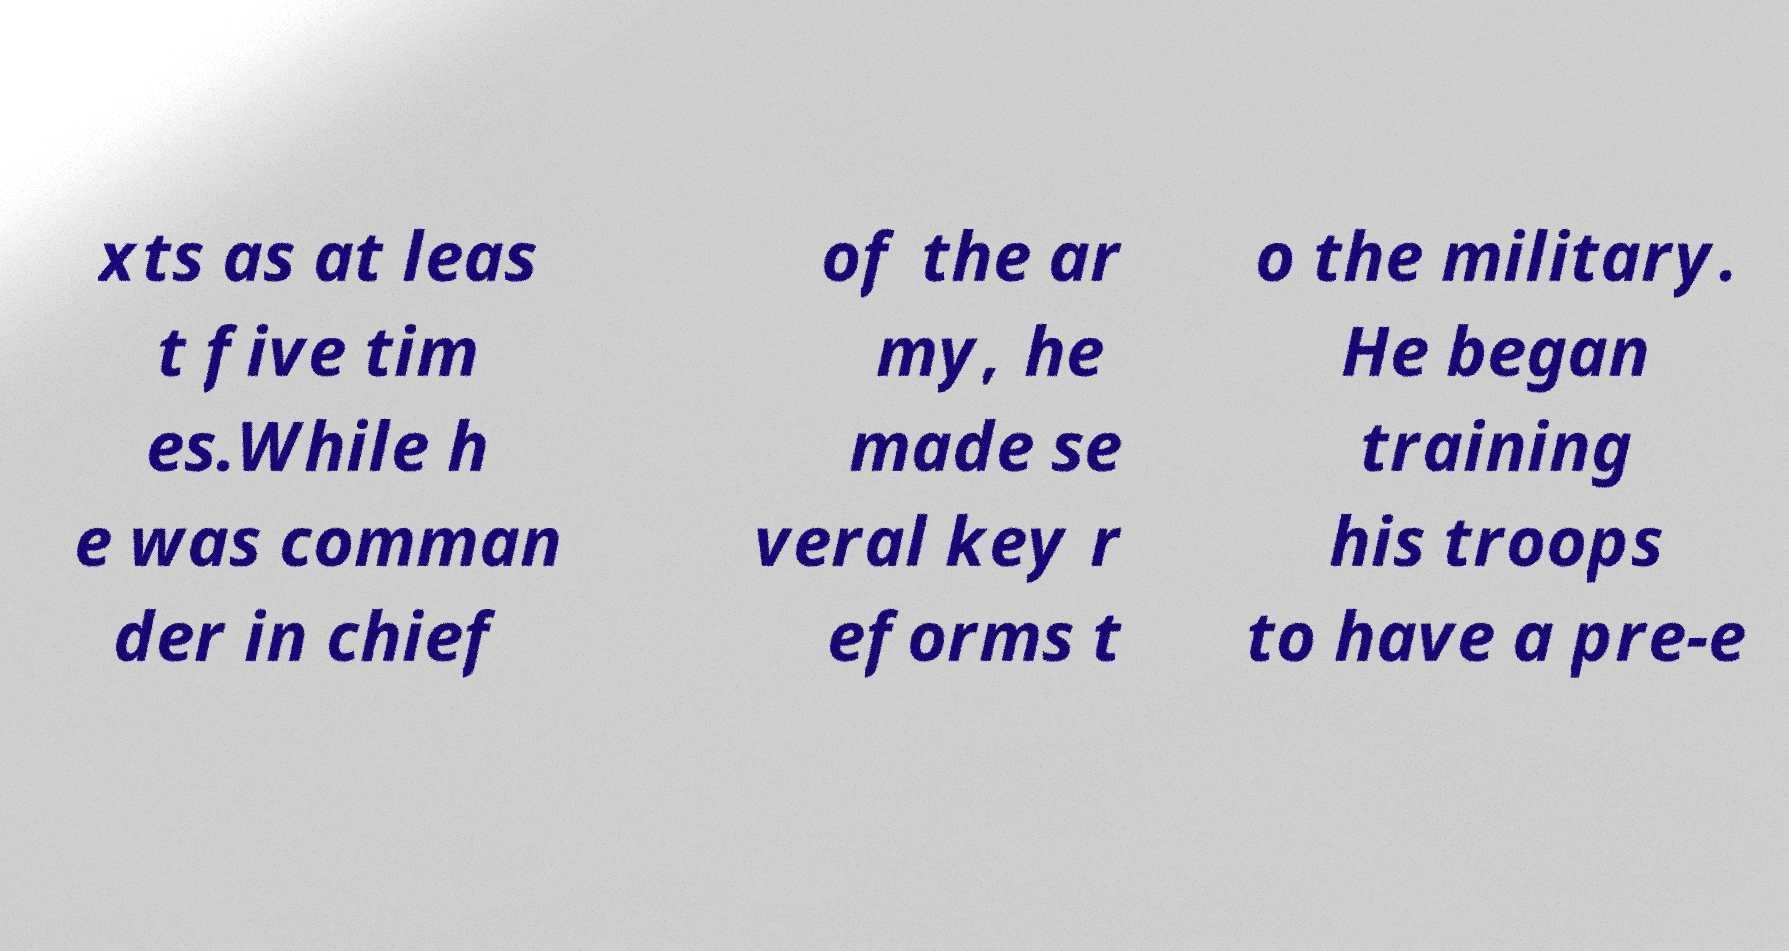Can you accurately transcribe the text from the provided image for me? xts as at leas t five tim es.While h e was comman der in chief of the ar my, he made se veral key r eforms t o the military. He began training his troops to have a pre-e 